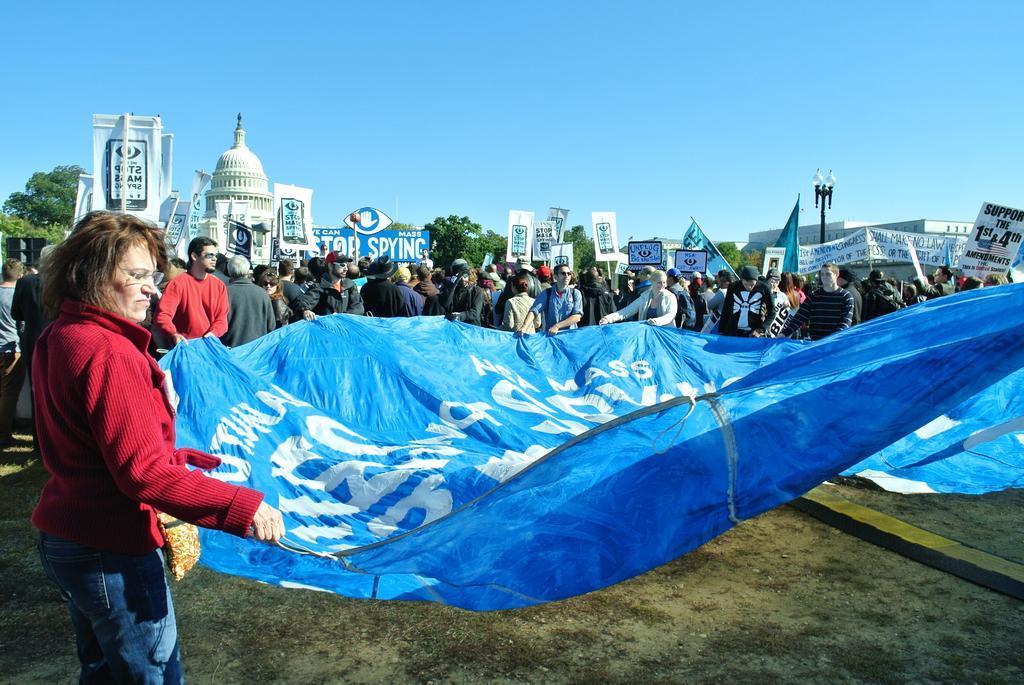Describe this image in one or two sentences. In this picture we can see a woman holding a cover sheet. And on the back there are many people standing. Even we can see a dome here. This is the board and these are the boards holding by the people. And on the background there are trees. And this is the sky. 